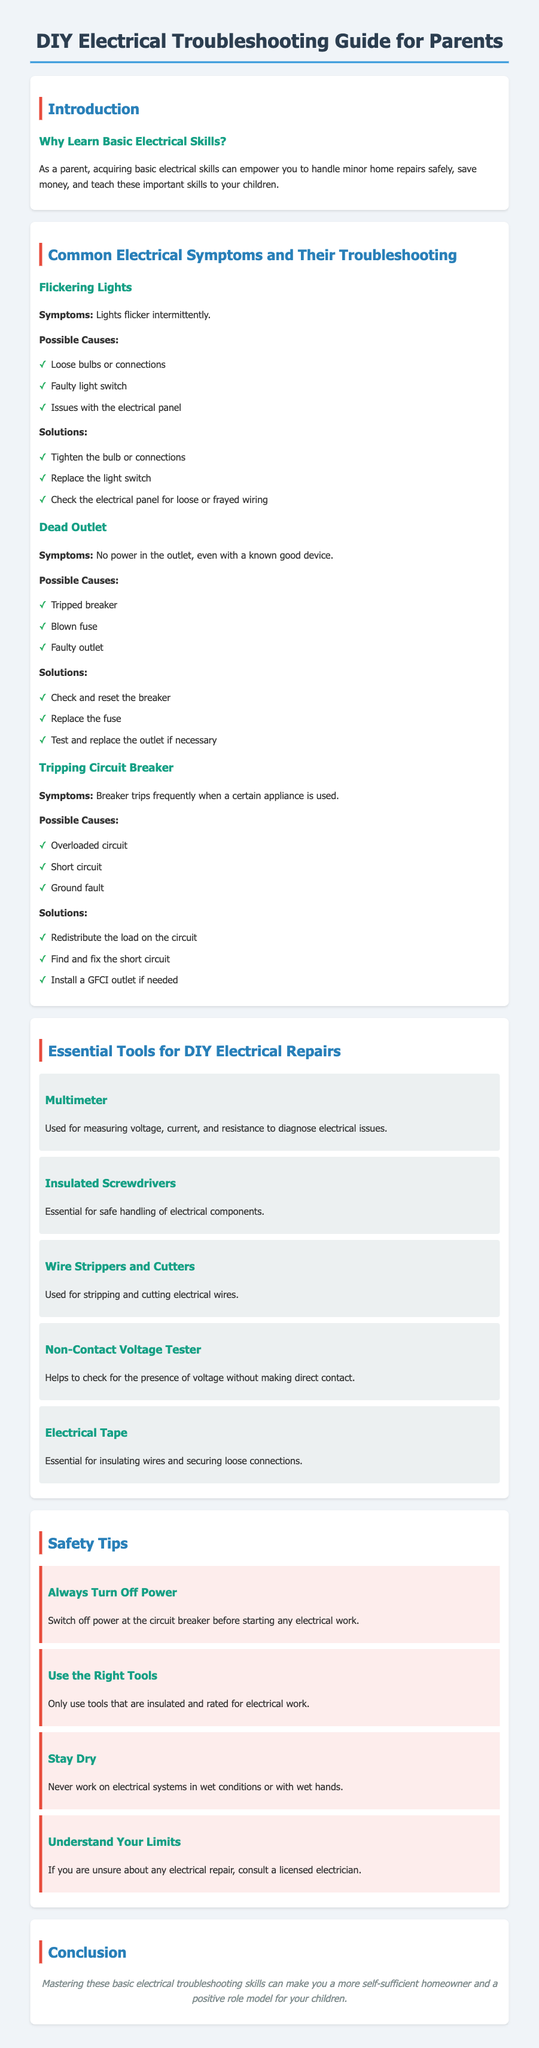What are the symptoms of flickering lights? The symptoms are lights flicker intermittently.
Answer: Lights flicker intermittently What is a possible cause of a dead outlet? One possible cause is a tripped breaker.
Answer: Tripped breaker What tool is used for measuring voltage? The tool used for measuring voltage is a multimeter.
Answer: Multimeter How should you respond if your circuit breaker trips frequently? You should redistribute the load on the circuit.
Answer: Redistribute the load How many safety tips are provided in the document? The document provides a total of four safety tips.
Answer: Four 